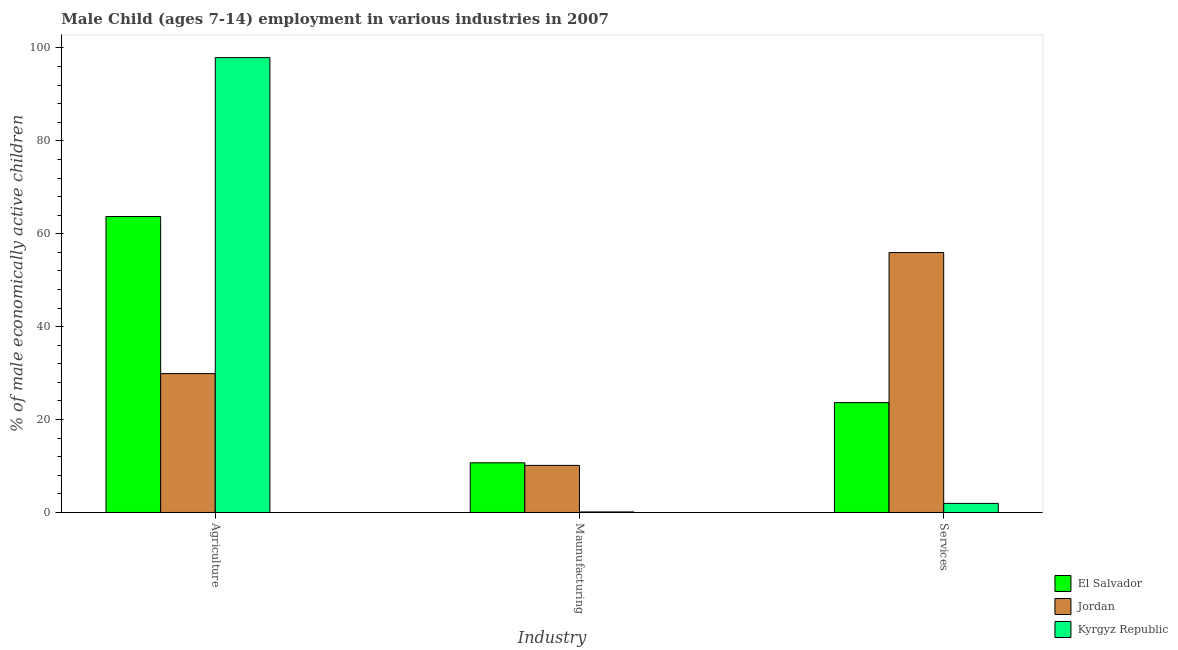How many different coloured bars are there?
Provide a short and direct response. 3. How many groups of bars are there?
Your response must be concise. 3. Are the number of bars on each tick of the X-axis equal?
Your answer should be very brief. Yes. How many bars are there on the 1st tick from the right?
Ensure brevity in your answer.  3. What is the label of the 2nd group of bars from the left?
Ensure brevity in your answer.  Maunufacturing. What is the percentage of economically active children in manufacturing in El Salvador?
Offer a terse response. 10.69. Across all countries, what is the maximum percentage of economically active children in services?
Provide a short and direct response. 55.96. Across all countries, what is the minimum percentage of economically active children in agriculture?
Keep it short and to the point. 29.9. In which country was the percentage of economically active children in services maximum?
Ensure brevity in your answer.  Jordan. In which country was the percentage of economically active children in services minimum?
Offer a very short reply. Kyrgyz Republic. What is the total percentage of economically active children in agriculture in the graph?
Offer a very short reply. 191.54. What is the difference between the percentage of economically active children in services in El Salvador and that in Jordan?
Provide a succinct answer. -32.31. What is the difference between the percentage of economically active children in services in Jordan and the percentage of economically active children in agriculture in Kyrgyz Republic?
Keep it short and to the point. -41.96. What is the average percentage of economically active children in manufacturing per country?
Offer a terse response. 6.98. What is the difference between the percentage of economically active children in manufacturing and percentage of economically active children in agriculture in El Salvador?
Provide a short and direct response. -53.03. In how many countries, is the percentage of economically active children in manufacturing greater than 40 %?
Offer a very short reply. 0. What is the ratio of the percentage of economically active children in agriculture in Jordan to that in Kyrgyz Republic?
Your response must be concise. 0.31. Is the percentage of economically active children in agriculture in Jordan less than that in Kyrgyz Republic?
Your response must be concise. Yes. What is the difference between the highest and the second highest percentage of economically active children in agriculture?
Ensure brevity in your answer.  34.2. What is the difference between the highest and the lowest percentage of economically active children in agriculture?
Your answer should be very brief. 68.02. In how many countries, is the percentage of economically active children in services greater than the average percentage of economically active children in services taken over all countries?
Offer a terse response. 1. Is the sum of the percentage of economically active children in services in Kyrgyz Republic and Jordan greater than the maximum percentage of economically active children in agriculture across all countries?
Your response must be concise. No. What does the 3rd bar from the left in Maunufacturing represents?
Provide a short and direct response. Kyrgyz Republic. What does the 2nd bar from the right in Agriculture represents?
Give a very brief answer. Jordan. How many countries are there in the graph?
Your answer should be compact. 3. Where does the legend appear in the graph?
Give a very brief answer. Bottom right. How many legend labels are there?
Your answer should be compact. 3. What is the title of the graph?
Offer a terse response. Male Child (ages 7-14) employment in various industries in 2007. What is the label or title of the X-axis?
Give a very brief answer. Industry. What is the label or title of the Y-axis?
Make the answer very short. % of male economically active children. What is the % of male economically active children of El Salvador in Agriculture?
Provide a succinct answer. 63.72. What is the % of male economically active children of Jordan in Agriculture?
Ensure brevity in your answer.  29.9. What is the % of male economically active children in Kyrgyz Republic in Agriculture?
Keep it short and to the point. 97.92. What is the % of male economically active children of El Salvador in Maunufacturing?
Keep it short and to the point. 10.69. What is the % of male economically active children in Jordan in Maunufacturing?
Your response must be concise. 10.14. What is the % of male economically active children in Kyrgyz Republic in Maunufacturing?
Give a very brief answer. 0.12. What is the % of male economically active children in El Salvador in Services?
Provide a succinct answer. 23.65. What is the % of male economically active children of Jordan in Services?
Your response must be concise. 55.96. What is the % of male economically active children of Kyrgyz Republic in Services?
Ensure brevity in your answer.  1.96. Across all Industry, what is the maximum % of male economically active children in El Salvador?
Provide a short and direct response. 63.72. Across all Industry, what is the maximum % of male economically active children in Jordan?
Your answer should be compact. 55.96. Across all Industry, what is the maximum % of male economically active children of Kyrgyz Republic?
Your answer should be very brief. 97.92. Across all Industry, what is the minimum % of male economically active children of El Salvador?
Keep it short and to the point. 10.69. Across all Industry, what is the minimum % of male economically active children of Jordan?
Offer a terse response. 10.14. Across all Industry, what is the minimum % of male economically active children of Kyrgyz Republic?
Your answer should be very brief. 0.12. What is the total % of male economically active children in El Salvador in the graph?
Your response must be concise. 98.06. What is the total % of male economically active children of Jordan in the graph?
Ensure brevity in your answer.  96. What is the difference between the % of male economically active children in El Salvador in Agriculture and that in Maunufacturing?
Your answer should be very brief. 53.03. What is the difference between the % of male economically active children of Jordan in Agriculture and that in Maunufacturing?
Offer a terse response. 19.76. What is the difference between the % of male economically active children in Kyrgyz Republic in Agriculture and that in Maunufacturing?
Offer a very short reply. 97.8. What is the difference between the % of male economically active children of El Salvador in Agriculture and that in Services?
Provide a succinct answer. 40.07. What is the difference between the % of male economically active children in Jordan in Agriculture and that in Services?
Offer a very short reply. -26.06. What is the difference between the % of male economically active children of Kyrgyz Republic in Agriculture and that in Services?
Your response must be concise. 95.96. What is the difference between the % of male economically active children in El Salvador in Maunufacturing and that in Services?
Give a very brief answer. -12.96. What is the difference between the % of male economically active children of Jordan in Maunufacturing and that in Services?
Make the answer very short. -45.82. What is the difference between the % of male economically active children of Kyrgyz Republic in Maunufacturing and that in Services?
Give a very brief answer. -1.84. What is the difference between the % of male economically active children in El Salvador in Agriculture and the % of male economically active children in Jordan in Maunufacturing?
Make the answer very short. 53.58. What is the difference between the % of male economically active children of El Salvador in Agriculture and the % of male economically active children of Kyrgyz Republic in Maunufacturing?
Provide a succinct answer. 63.6. What is the difference between the % of male economically active children in Jordan in Agriculture and the % of male economically active children in Kyrgyz Republic in Maunufacturing?
Your response must be concise. 29.78. What is the difference between the % of male economically active children in El Salvador in Agriculture and the % of male economically active children in Jordan in Services?
Make the answer very short. 7.76. What is the difference between the % of male economically active children in El Salvador in Agriculture and the % of male economically active children in Kyrgyz Republic in Services?
Provide a short and direct response. 61.76. What is the difference between the % of male economically active children in Jordan in Agriculture and the % of male economically active children in Kyrgyz Republic in Services?
Keep it short and to the point. 27.94. What is the difference between the % of male economically active children of El Salvador in Maunufacturing and the % of male economically active children of Jordan in Services?
Provide a short and direct response. -45.27. What is the difference between the % of male economically active children in El Salvador in Maunufacturing and the % of male economically active children in Kyrgyz Republic in Services?
Offer a terse response. 8.73. What is the difference between the % of male economically active children in Jordan in Maunufacturing and the % of male economically active children in Kyrgyz Republic in Services?
Ensure brevity in your answer.  8.18. What is the average % of male economically active children in El Salvador per Industry?
Offer a terse response. 32.69. What is the average % of male economically active children in Jordan per Industry?
Your response must be concise. 32. What is the average % of male economically active children of Kyrgyz Republic per Industry?
Your answer should be compact. 33.33. What is the difference between the % of male economically active children of El Salvador and % of male economically active children of Jordan in Agriculture?
Provide a succinct answer. 33.82. What is the difference between the % of male economically active children of El Salvador and % of male economically active children of Kyrgyz Republic in Agriculture?
Keep it short and to the point. -34.2. What is the difference between the % of male economically active children in Jordan and % of male economically active children in Kyrgyz Republic in Agriculture?
Give a very brief answer. -68.02. What is the difference between the % of male economically active children of El Salvador and % of male economically active children of Jordan in Maunufacturing?
Offer a very short reply. 0.55. What is the difference between the % of male economically active children in El Salvador and % of male economically active children in Kyrgyz Republic in Maunufacturing?
Give a very brief answer. 10.57. What is the difference between the % of male economically active children of Jordan and % of male economically active children of Kyrgyz Republic in Maunufacturing?
Ensure brevity in your answer.  10.02. What is the difference between the % of male economically active children of El Salvador and % of male economically active children of Jordan in Services?
Provide a short and direct response. -32.31. What is the difference between the % of male economically active children of El Salvador and % of male economically active children of Kyrgyz Republic in Services?
Make the answer very short. 21.69. What is the ratio of the % of male economically active children in El Salvador in Agriculture to that in Maunufacturing?
Make the answer very short. 5.96. What is the ratio of the % of male economically active children in Jordan in Agriculture to that in Maunufacturing?
Your response must be concise. 2.95. What is the ratio of the % of male economically active children of Kyrgyz Republic in Agriculture to that in Maunufacturing?
Provide a succinct answer. 816. What is the ratio of the % of male economically active children in El Salvador in Agriculture to that in Services?
Provide a short and direct response. 2.69. What is the ratio of the % of male economically active children in Jordan in Agriculture to that in Services?
Provide a succinct answer. 0.53. What is the ratio of the % of male economically active children in Kyrgyz Republic in Agriculture to that in Services?
Your answer should be very brief. 49.96. What is the ratio of the % of male economically active children in El Salvador in Maunufacturing to that in Services?
Offer a very short reply. 0.45. What is the ratio of the % of male economically active children in Jordan in Maunufacturing to that in Services?
Offer a very short reply. 0.18. What is the ratio of the % of male economically active children in Kyrgyz Republic in Maunufacturing to that in Services?
Ensure brevity in your answer.  0.06. What is the difference between the highest and the second highest % of male economically active children in El Salvador?
Your answer should be very brief. 40.07. What is the difference between the highest and the second highest % of male economically active children of Jordan?
Make the answer very short. 26.06. What is the difference between the highest and the second highest % of male economically active children in Kyrgyz Republic?
Provide a succinct answer. 95.96. What is the difference between the highest and the lowest % of male economically active children in El Salvador?
Provide a succinct answer. 53.03. What is the difference between the highest and the lowest % of male economically active children in Jordan?
Provide a short and direct response. 45.82. What is the difference between the highest and the lowest % of male economically active children of Kyrgyz Republic?
Your answer should be compact. 97.8. 